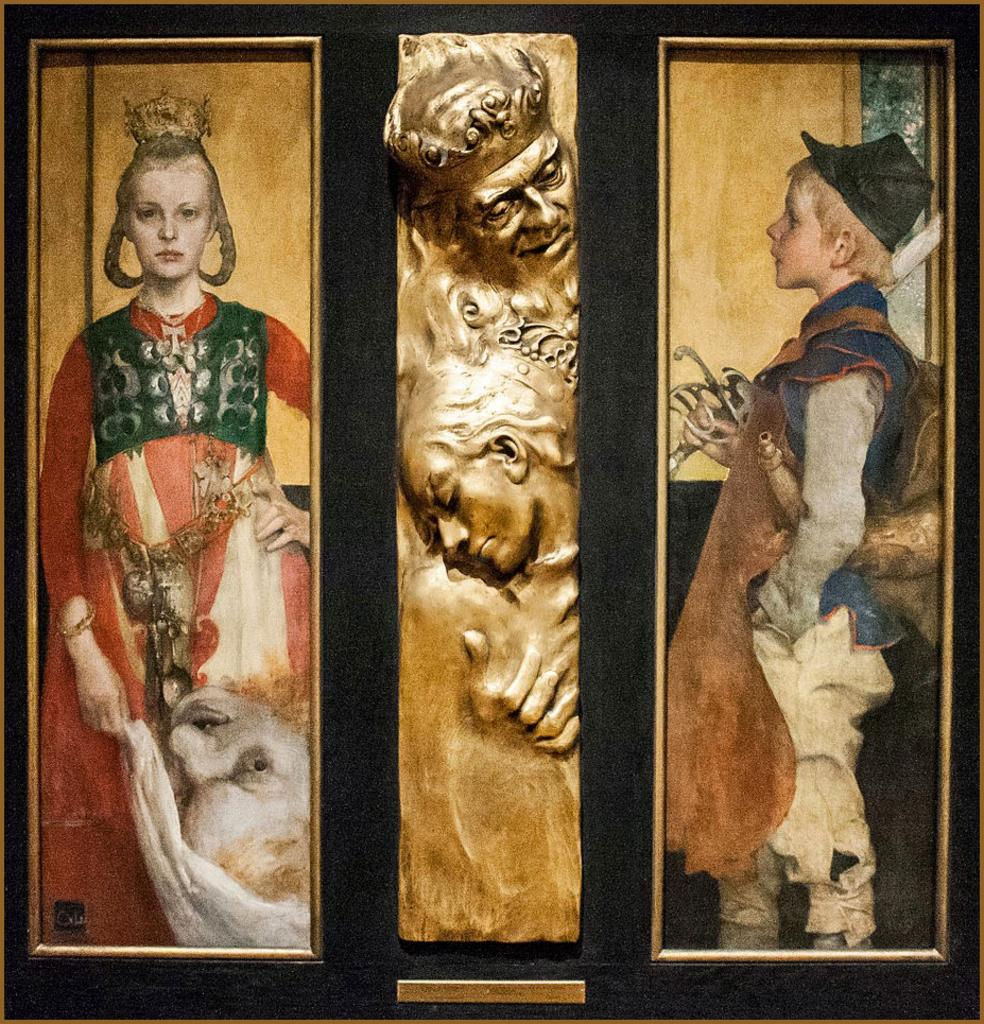How many frames are present in the image? There are two different frames in the image. What can be seen in the first frame? In one frame, there is a girl. What can be seen in the second frame? In another frame, there is a boy. What type of object is present in the image? There is a sculpture in the image. What is the color of the sculpture? The sculpture is gold in color. How many tomatoes are on the sculpture in the image? There are no tomatoes present in the image; the sculpture is gold in color. What is the interest rate of the sculpture in the image? The sculpture is not related to interest rates; it is a gold-colored sculpture. 